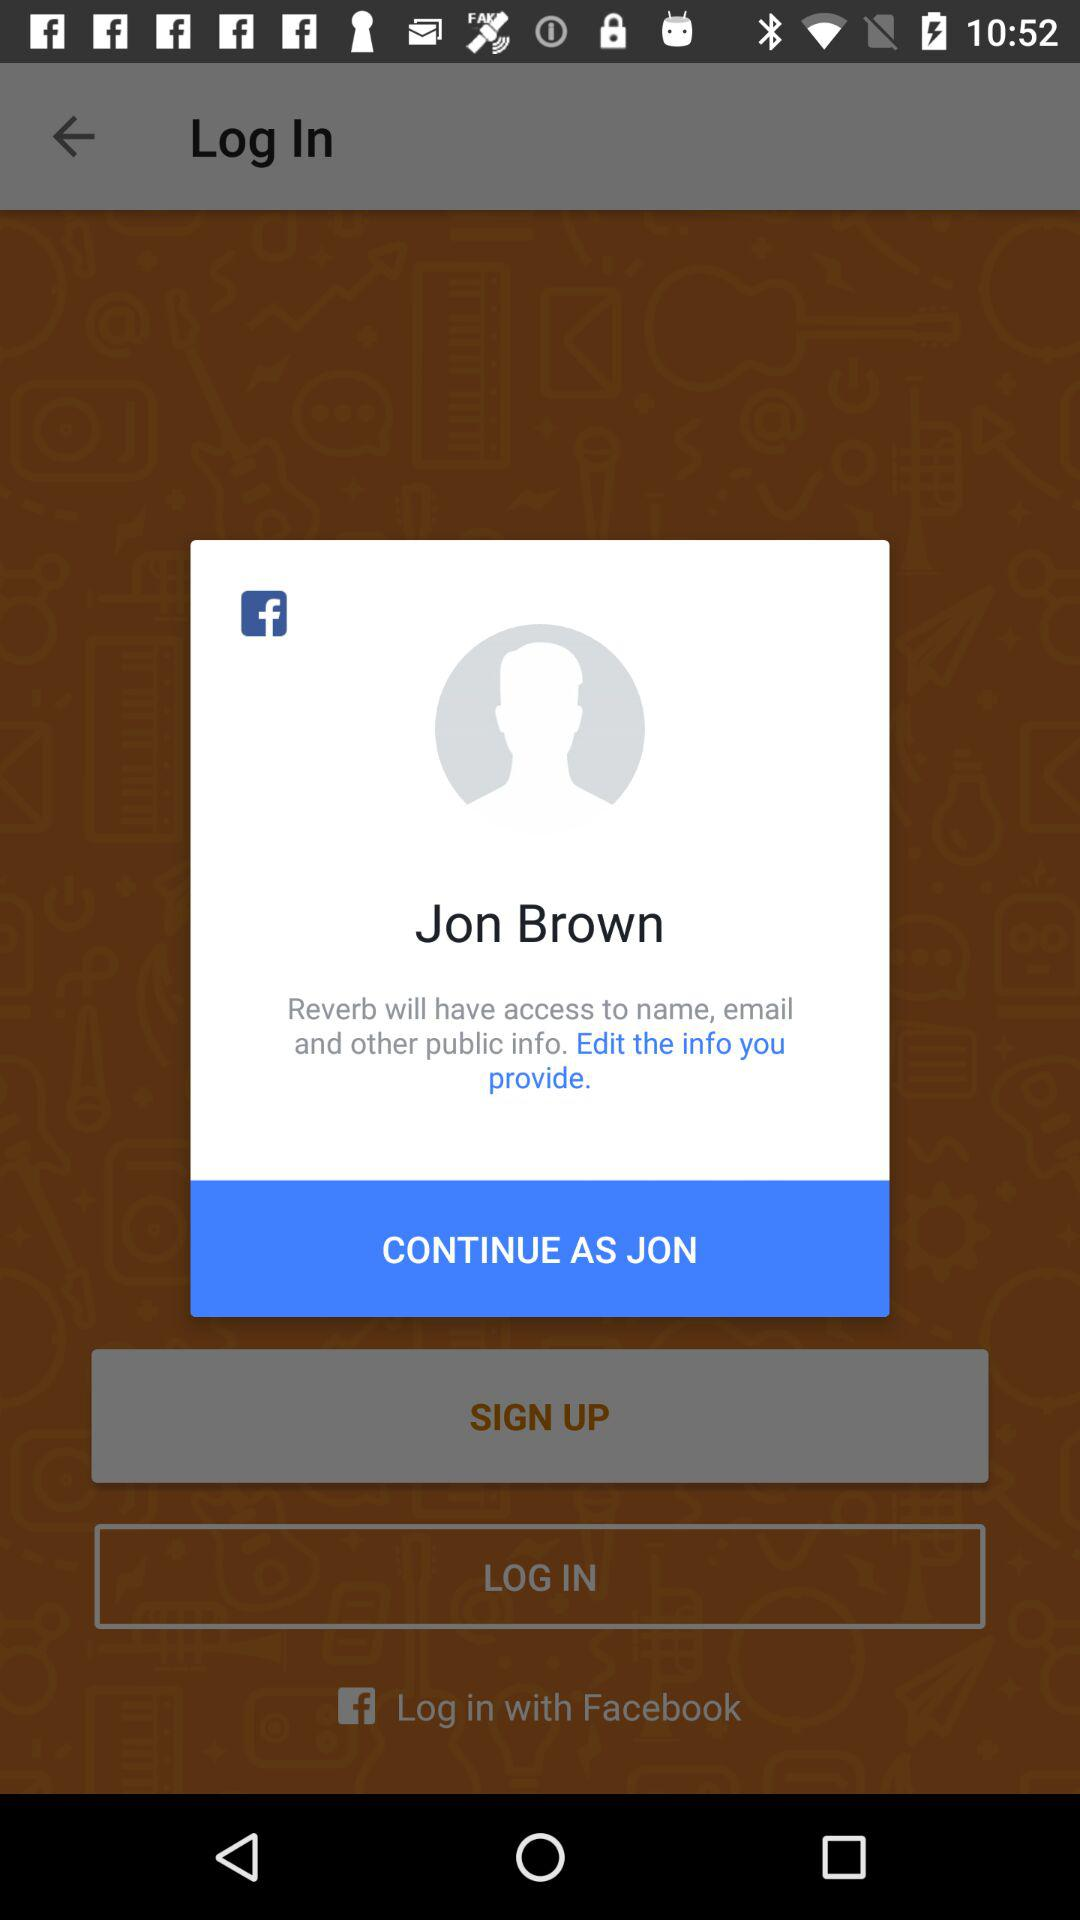What application has asked for permission? The application that has asked for permission is "Reverb". 